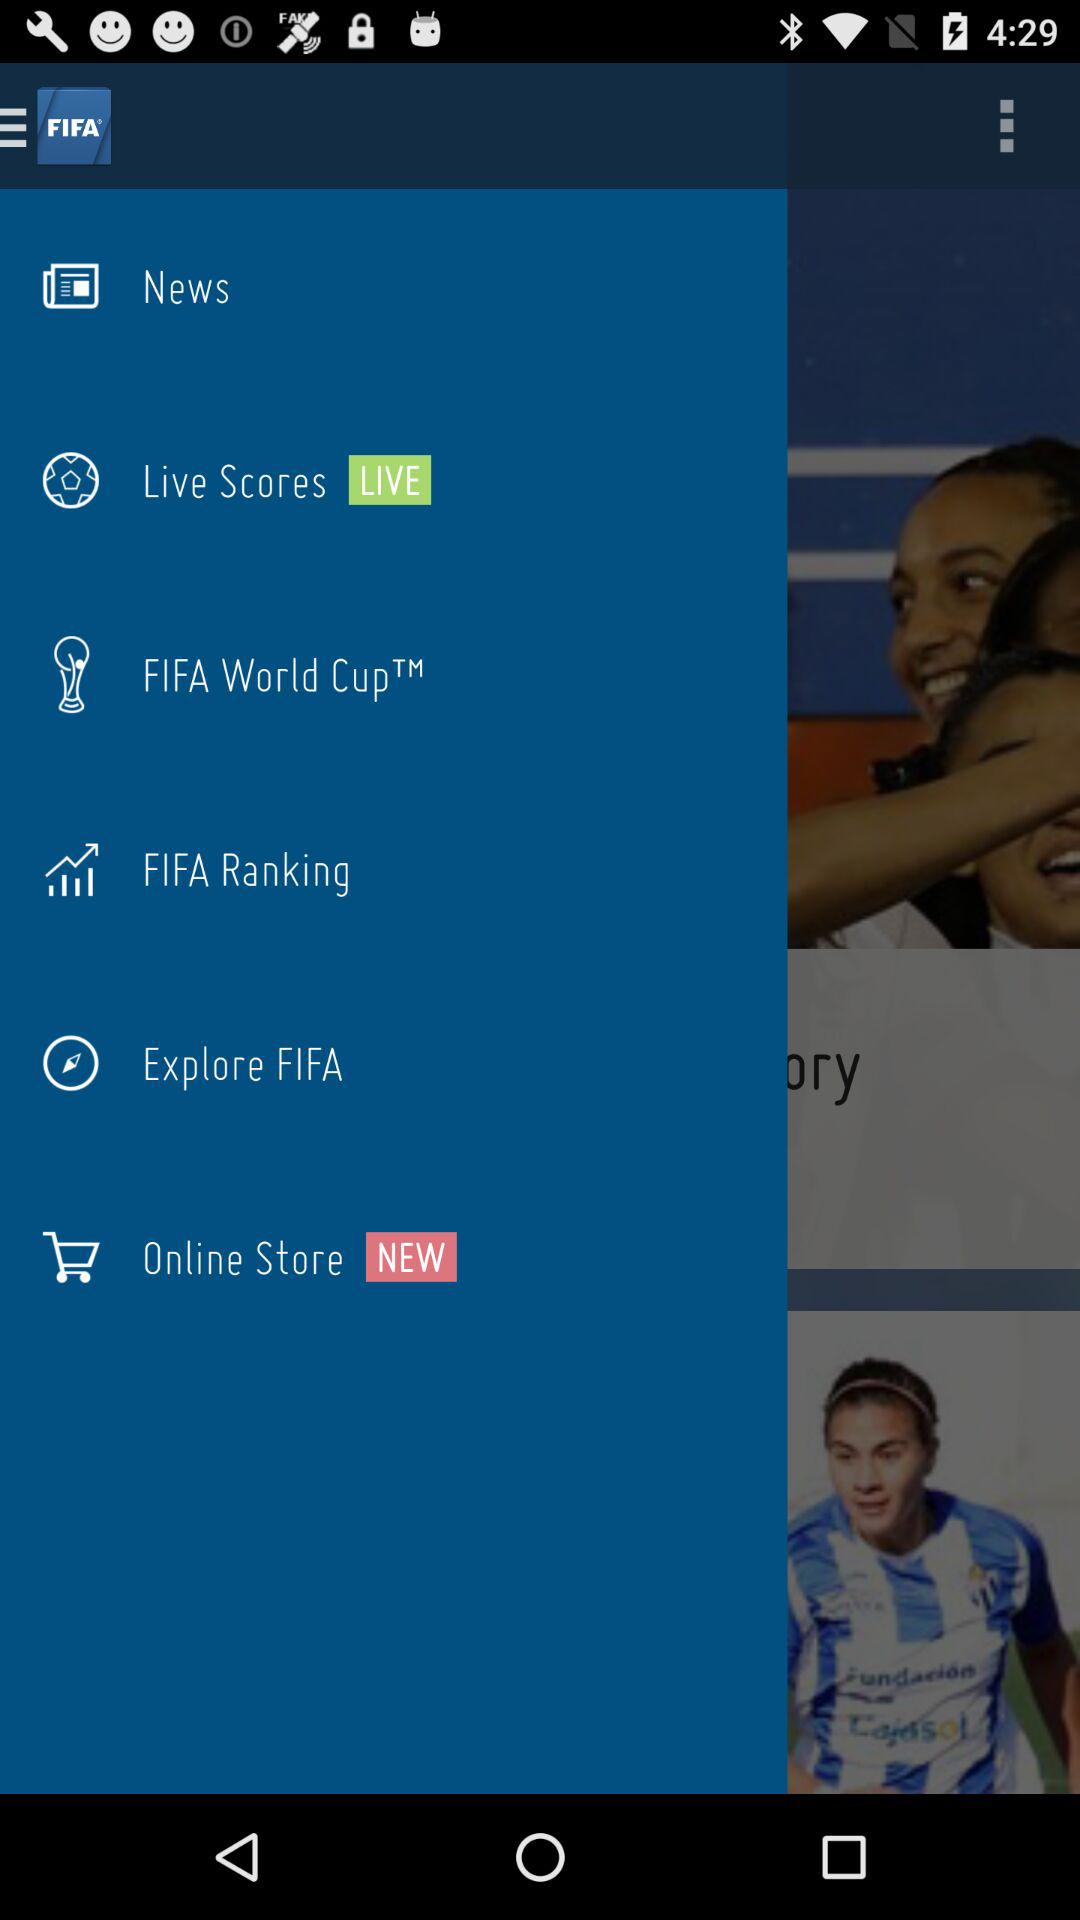How often are "Live Scores" updated?
When the provided information is insufficient, respond with <no answer>. <no answer> 